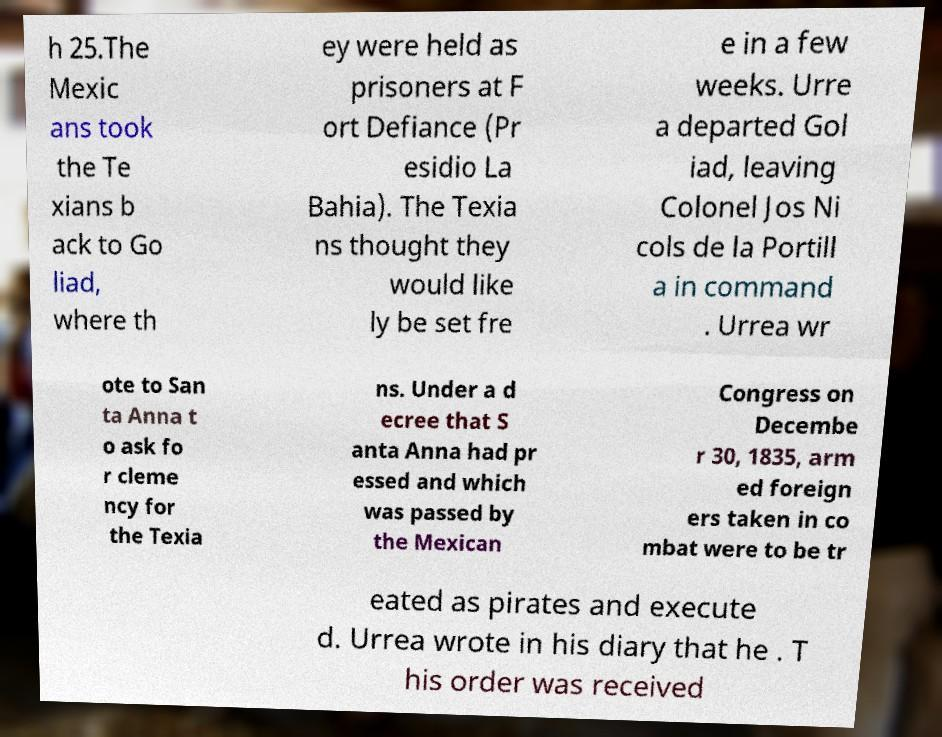What messages or text are displayed in this image? I need them in a readable, typed format. h 25.The Mexic ans took the Te xians b ack to Go liad, where th ey were held as prisoners at F ort Defiance (Pr esidio La Bahia). The Texia ns thought they would like ly be set fre e in a few weeks. Urre a departed Gol iad, leaving Colonel Jos Ni cols de la Portill a in command . Urrea wr ote to San ta Anna t o ask fo r cleme ncy for the Texia ns. Under a d ecree that S anta Anna had pr essed and which was passed by the Mexican Congress on Decembe r 30, 1835, arm ed foreign ers taken in co mbat were to be tr eated as pirates and execute d. Urrea wrote in his diary that he . T his order was received 